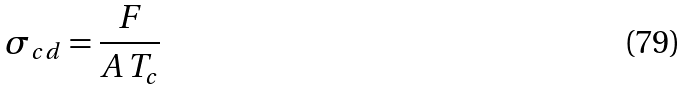Convert formula to latex. <formula><loc_0><loc_0><loc_500><loc_500>\sigma _ { c d } = \frac { F } { A \, T _ { c } }</formula> 